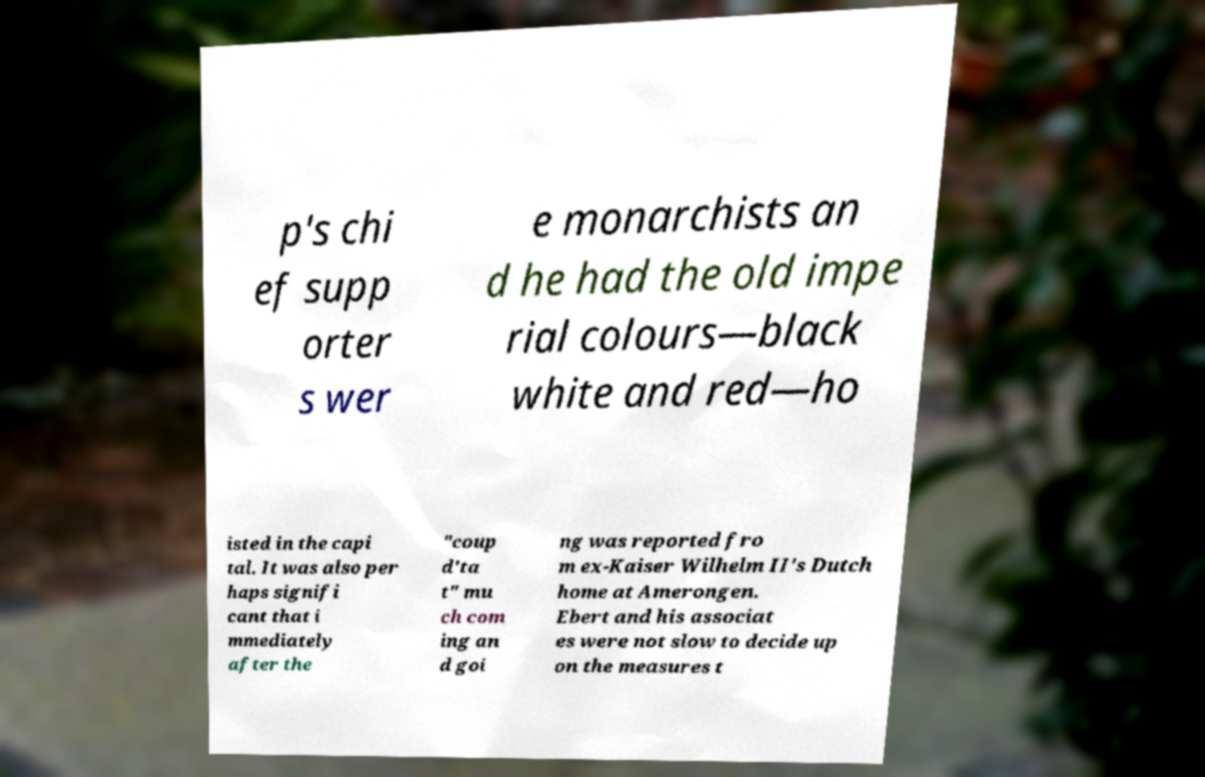Please read and relay the text visible in this image. What does it say? p's chi ef supp orter s wer e monarchists an d he had the old impe rial colours—black white and red—ho isted in the capi tal. It was also per haps signifi cant that i mmediately after the "coup d'ta t" mu ch com ing an d goi ng was reported fro m ex-Kaiser Wilhelm II's Dutch home at Amerongen. Ebert and his associat es were not slow to decide up on the measures t 